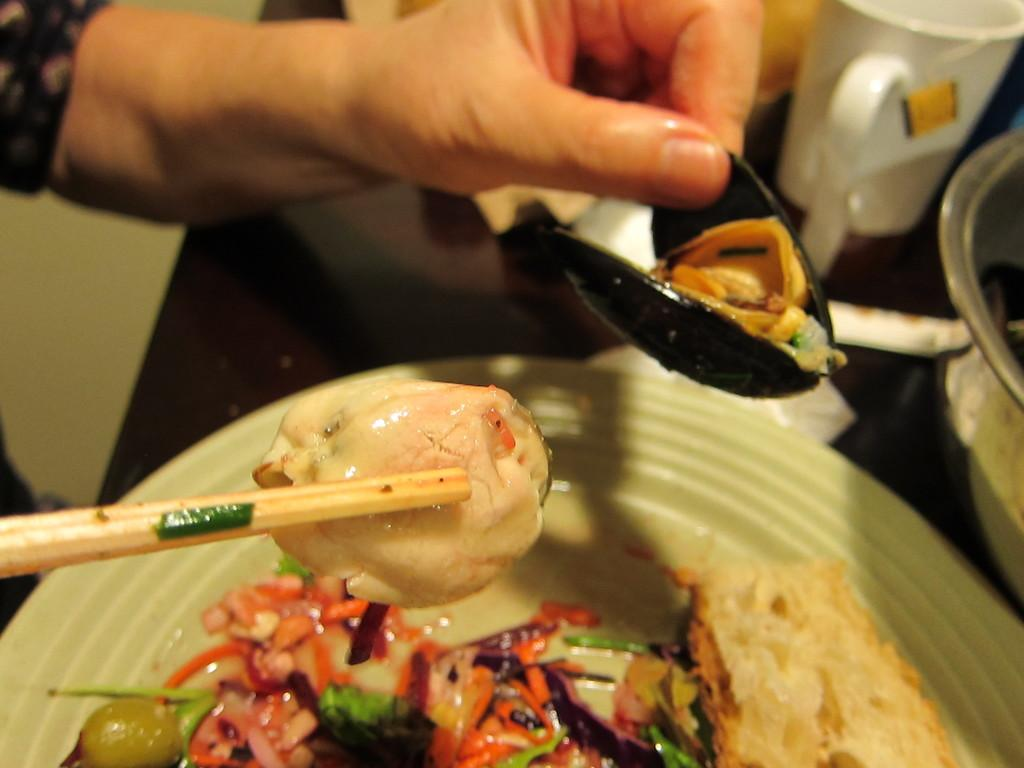What is the main subject of the image? There is a guy in the image. What is the guy holding in one hand? The guy is holding an oyster in one hand. What is the guy holding in the other hand? The guy is holding a food item with chopsticks in the other hand. What is present on the table in the image? There is a table in the image, and there is a plate with food items on the table. What type of scarf is the guy wearing in the image? There is no scarf present in the image; the guy is not wearing any clothing items around his neck. 